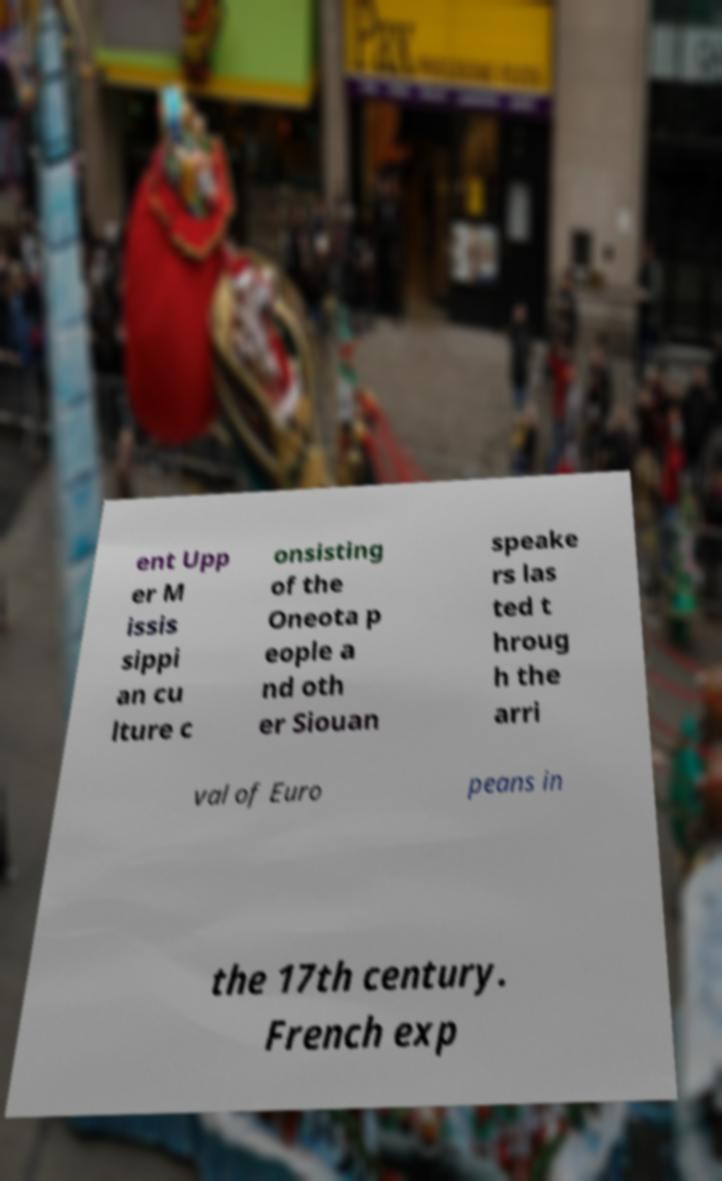Could you assist in decoding the text presented in this image and type it out clearly? ent Upp er M issis sippi an cu lture c onsisting of the Oneota p eople a nd oth er Siouan speake rs las ted t hroug h the arri val of Euro peans in the 17th century. French exp 